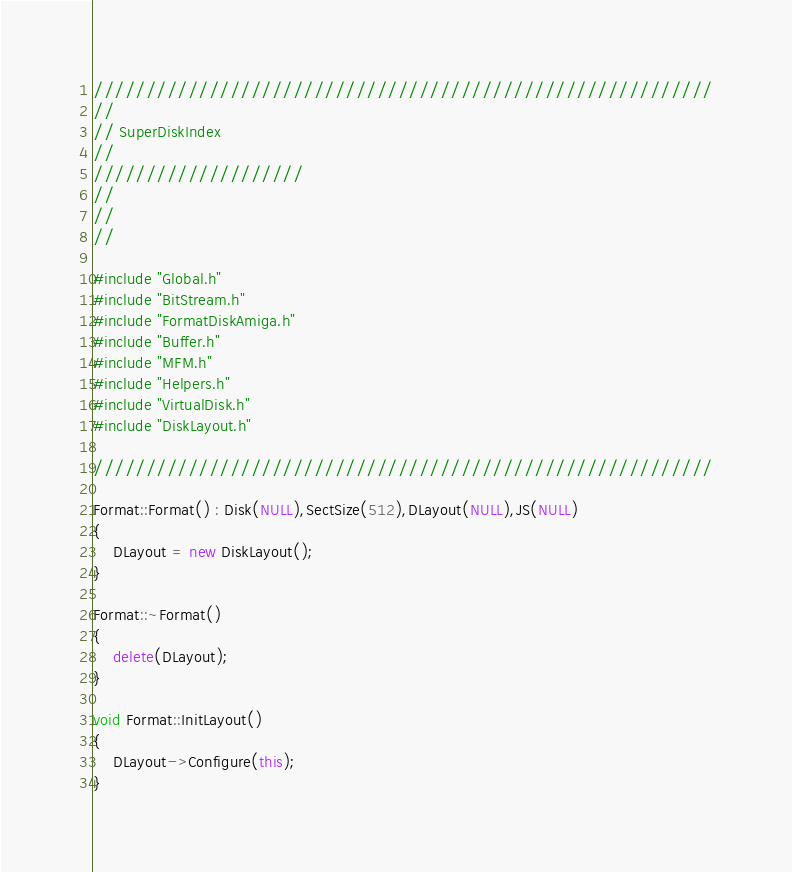Convert code to text. <code><loc_0><loc_0><loc_500><loc_500><_C++_>///////////////////////////////////////////////////////////
//
// SuperDiskIndex
//
////////////////////
//
// 
//

#include "Global.h"
#include "BitStream.h"
#include "FormatDiskAmiga.h"
#include "Buffer.h"
#include "MFM.h"
#include "Helpers.h"
#include "VirtualDisk.h"
#include "DiskLayout.h"

///////////////////////////////////////////////////////////

Format::Format() : Disk(NULL),SectSize(512),DLayout(NULL),JS(NULL)
{
	DLayout = new DiskLayout();
}

Format::~Format()
{
	delete(DLayout);
}

void Format::InitLayout()
{
	DLayout->Configure(this);
}</code> 